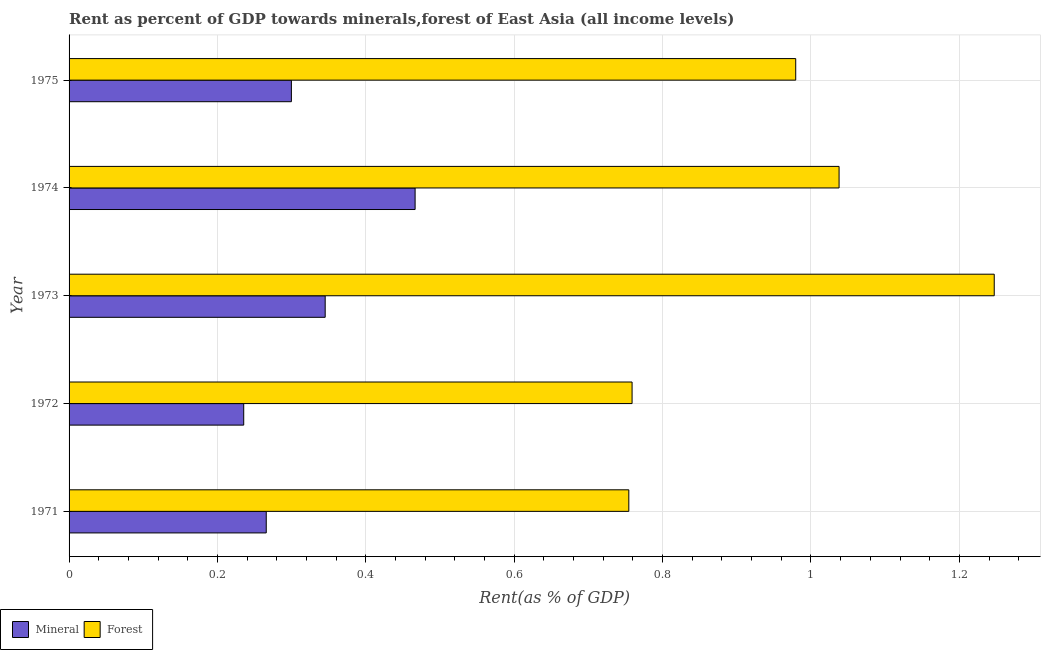How many different coloured bars are there?
Your answer should be very brief. 2. How many groups of bars are there?
Your response must be concise. 5. What is the label of the 2nd group of bars from the top?
Make the answer very short. 1974. In how many cases, is the number of bars for a given year not equal to the number of legend labels?
Provide a short and direct response. 0. What is the mineral rent in 1974?
Provide a short and direct response. 0.47. Across all years, what is the maximum mineral rent?
Keep it short and to the point. 0.47. Across all years, what is the minimum mineral rent?
Ensure brevity in your answer.  0.24. In which year was the forest rent minimum?
Make the answer very short. 1971. What is the total forest rent in the graph?
Keep it short and to the point. 4.78. What is the difference between the forest rent in 1973 and that in 1975?
Ensure brevity in your answer.  0.27. What is the difference between the mineral rent in 1974 and the forest rent in 1971?
Your response must be concise. -0.29. What is the average mineral rent per year?
Offer a terse response. 0.32. In the year 1974, what is the difference between the mineral rent and forest rent?
Offer a terse response. -0.57. In how many years, is the forest rent greater than 0.88 %?
Provide a succinct answer. 3. What is the ratio of the mineral rent in 1973 to that in 1975?
Ensure brevity in your answer.  1.15. What is the difference between the highest and the second highest mineral rent?
Your answer should be compact. 0.12. What is the difference between the highest and the lowest mineral rent?
Your response must be concise. 0.23. In how many years, is the mineral rent greater than the average mineral rent taken over all years?
Offer a very short reply. 2. What does the 2nd bar from the top in 1974 represents?
Offer a terse response. Mineral. What does the 1st bar from the bottom in 1971 represents?
Your answer should be compact. Mineral. Are all the bars in the graph horizontal?
Offer a terse response. Yes. How many years are there in the graph?
Your response must be concise. 5. Are the values on the major ticks of X-axis written in scientific E-notation?
Offer a terse response. No. How many legend labels are there?
Give a very brief answer. 2. What is the title of the graph?
Ensure brevity in your answer.  Rent as percent of GDP towards minerals,forest of East Asia (all income levels). Does "Resident workers" appear as one of the legend labels in the graph?
Keep it short and to the point. No. What is the label or title of the X-axis?
Your answer should be compact. Rent(as % of GDP). What is the Rent(as % of GDP) in Mineral in 1971?
Your response must be concise. 0.27. What is the Rent(as % of GDP) of Forest in 1971?
Offer a very short reply. 0.75. What is the Rent(as % of GDP) of Mineral in 1972?
Your response must be concise. 0.24. What is the Rent(as % of GDP) in Forest in 1972?
Give a very brief answer. 0.76. What is the Rent(as % of GDP) in Mineral in 1973?
Keep it short and to the point. 0.35. What is the Rent(as % of GDP) in Forest in 1973?
Provide a short and direct response. 1.25. What is the Rent(as % of GDP) of Mineral in 1974?
Give a very brief answer. 0.47. What is the Rent(as % of GDP) of Forest in 1974?
Your response must be concise. 1.04. What is the Rent(as % of GDP) in Mineral in 1975?
Make the answer very short. 0.3. What is the Rent(as % of GDP) of Forest in 1975?
Offer a very short reply. 0.98. Across all years, what is the maximum Rent(as % of GDP) in Mineral?
Keep it short and to the point. 0.47. Across all years, what is the maximum Rent(as % of GDP) in Forest?
Ensure brevity in your answer.  1.25. Across all years, what is the minimum Rent(as % of GDP) of Mineral?
Your answer should be compact. 0.24. Across all years, what is the minimum Rent(as % of GDP) of Forest?
Give a very brief answer. 0.75. What is the total Rent(as % of GDP) of Mineral in the graph?
Offer a terse response. 1.61. What is the total Rent(as % of GDP) of Forest in the graph?
Your answer should be compact. 4.78. What is the difference between the Rent(as % of GDP) of Mineral in 1971 and that in 1972?
Offer a very short reply. 0.03. What is the difference between the Rent(as % of GDP) in Forest in 1971 and that in 1972?
Provide a short and direct response. -0. What is the difference between the Rent(as % of GDP) of Mineral in 1971 and that in 1973?
Your answer should be compact. -0.08. What is the difference between the Rent(as % of GDP) of Forest in 1971 and that in 1973?
Give a very brief answer. -0.49. What is the difference between the Rent(as % of GDP) of Mineral in 1971 and that in 1974?
Make the answer very short. -0.2. What is the difference between the Rent(as % of GDP) of Forest in 1971 and that in 1974?
Your answer should be very brief. -0.28. What is the difference between the Rent(as % of GDP) of Mineral in 1971 and that in 1975?
Give a very brief answer. -0.03. What is the difference between the Rent(as % of GDP) in Forest in 1971 and that in 1975?
Your response must be concise. -0.23. What is the difference between the Rent(as % of GDP) of Mineral in 1972 and that in 1973?
Offer a terse response. -0.11. What is the difference between the Rent(as % of GDP) in Forest in 1972 and that in 1973?
Make the answer very short. -0.49. What is the difference between the Rent(as % of GDP) in Mineral in 1972 and that in 1974?
Make the answer very short. -0.23. What is the difference between the Rent(as % of GDP) of Forest in 1972 and that in 1974?
Your answer should be very brief. -0.28. What is the difference between the Rent(as % of GDP) of Mineral in 1972 and that in 1975?
Offer a very short reply. -0.06. What is the difference between the Rent(as % of GDP) in Forest in 1972 and that in 1975?
Keep it short and to the point. -0.22. What is the difference between the Rent(as % of GDP) of Mineral in 1973 and that in 1974?
Make the answer very short. -0.12. What is the difference between the Rent(as % of GDP) in Forest in 1973 and that in 1974?
Make the answer very short. 0.21. What is the difference between the Rent(as % of GDP) in Mineral in 1973 and that in 1975?
Offer a very short reply. 0.05. What is the difference between the Rent(as % of GDP) in Forest in 1973 and that in 1975?
Provide a short and direct response. 0.27. What is the difference between the Rent(as % of GDP) of Mineral in 1974 and that in 1975?
Ensure brevity in your answer.  0.17. What is the difference between the Rent(as % of GDP) in Forest in 1974 and that in 1975?
Your answer should be compact. 0.06. What is the difference between the Rent(as % of GDP) of Mineral in 1971 and the Rent(as % of GDP) of Forest in 1972?
Make the answer very short. -0.49. What is the difference between the Rent(as % of GDP) in Mineral in 1971 and the Rent(as % of GDP) in Forest in 1973?
Give a very brief answer. -0.98. What is the difference between the Rent(as % of GDP) of Mineral in 1971 and the Rent(as % of GDP) of Forest in 1974?
Your response must be concise. -0.77. What is the difference between the Rent(as % of GDP) in Mineral in 1971 and the Rent(as % of GDP) in Forest in 1975?
Ensure brevity in your answer.  -0.71. What is the difference between the Rent(as % of GDP) in Mineral in 1972 and the Rent(as % of GDP) in Forest in 1973?
Ensure brevity in your answer.  -1.01. What is the difference between the Rent(as % of GDP) of Mineral in 1972 and the Rent(as % of GDP) of Forest in 1974?
Ensure brevity in your answer.  -0.8. What is the difference between the Rent(as % of GDP) in Mineral in 1972 and the Rent(as % of GDP) in Forest in 1975?
Provide a short and direct response. -0.74. What is the difference between the Rent(as % of GDP) in Mineral in 1973 and the Rent(as % of GDP) in Forest in 1974?
Provide a short and direct response. -0.69. What is the difference between the Rent(as % of GDP) of Mineral in 1973 and the Rent(as % of GDP) of Forest in 1975?
Offer a very short reply. -0.63. What is the difference between the Rent(as % of GDP) in Mineral in 1974 and the Rent(as % of GDP) in Forest in 1975?
Keep it short and to the point. -0.51. What is the average Rent(as % of GDP) in Mineral per year?
Offer a very short reply. 0.32. What is the average Rent(as % of GDP) of Forest per year?
Offer a terse response. 0.96. In the year 1971, what is the difference between the Rent(as % of GDP) in Mineral and Rent(as % of GDP) in Forest?
Ensure brevity in your answer.  -0.49. In the year 1972, what is the difference between the Rent(as % of GDP) in Mineral and Rent(as % of GDP) in Forest?
Offer a terse response. -0.52. In the year 1973, what is the difference between the Rent(as % of GDP) in Mineral and Rent(as % of GDP) in Forest?
Offer a very short reply. -0.9. In the year 1974, what is the difference between the Rent(as % of GDP) of Mineral and Rent(as % of GDP) of Forest?
Your response must be concise. -0.57. In the year 1975, what is the difference between the Rent(as % of GDP) of Mineral and Rent(as % of GDP) of Forest?
Your answer should be very brief. -0.68. What is the ratio of the Rent(as % of GDP) in Mineral in 1971 to that in 1972?
Offer a very short reply. 1.13. What is the ratio of the Rent(as % of GDP) in Forest in 1971 to that in 1972?
Provide a short and direct response. 0.99. What is the ratio of the Rent(as % of GDP) of Mineral in 1971 to that in 1973?
Provide a short and direct response. 0.77. What is the ratio of the Rent(as % of GDP) in Forest in 1971 to that in 1973?
Make the answer very short. 0.6. What is the ratio of the Rent(as % of GDP) in Mineral in 1971 to that in 1974?
Your answer should be compact. 0.57. What is the ratio of the Rent(as % of GDP) of Forest in 1971 to that in 1974?
Give a very brief answer. 0.73. What is the ratio of the Rent(as % of GDP) in Mineral in 1971 to that in 1975?
Your response must be concise. 0.89. What is the ratio of the Rent(as % of GDP) of Forest in 1971 to that in 1975?
Give a very brief answer. 0.77. What is the ratio of the Rent(as % of GDP) of Mineral in 1972 to that in 1973?
Provide a succinct answer. 0.68. What is the ratio of the Rent(as % of GDP) in Forest in 1972 to that in 1973?
Keep it short and to the point. 0.61. What is the ratio of the Rent(as % of GDP) in Mineral in 1972 to that in 1974?
Offer a terse response. 0.5. What is the ratio of the Rent(as % of GDP) of Forest in 1972 to that in 1974?
Your response must be concise. 0.73. What is the ratio of the Rent(as % of GDP) of Mineral in 1972 to that in 1975?
Provide a short and direct response. 0.79. What is the ratio of the Rent(as % of GDP) of Forest in 1972 to that in 1975?
Your answer should be very brief. 0.77. What is the ratio of the Rent(as % of GDP) in Mineral in 1973 to that in 1974?
Provide a succinct answer. 0.74. What is the ratio of the Rent(as % of GDP) of Forest in 1973 to that in 1974?
Offer a very short reply. 1.2. What is the ratio of the Rent(as % of GDP) of Mineral in 1973 to that in 1975?
Your response must be concise. 1.15. What is the ratio of the Rent(as % of GDP) in Forest in 1973 to that in 1975?
Provide a short and direct response. 1.27. What is the ratio of the Rent(as % of GDP) in Mineral in 1974 to that in 1975?
Keep it short and to the point. 1.56. What is the ratio of the Rent(as % of GDP) of Forest in 1974 to that in 1975?
Your response must be concise. 1.06. What is the difference between the highest and the second highest Rent(as % of GDP) of Mineral?
Offer a terse response. 0.12. What is the difference between the highest and the second highest Rent(as % of GDP) in Forest?
Keep it short and to the point. 0.21. What is the difference between the highest and the lowest Rent(as % of GDP) in Mineral?
Keep it short and to the point. 0.23. What is the difference between the highest and the lowest Rent(as % of GDP) of Forest?
Ensure brevity in your answer.  0.49. 